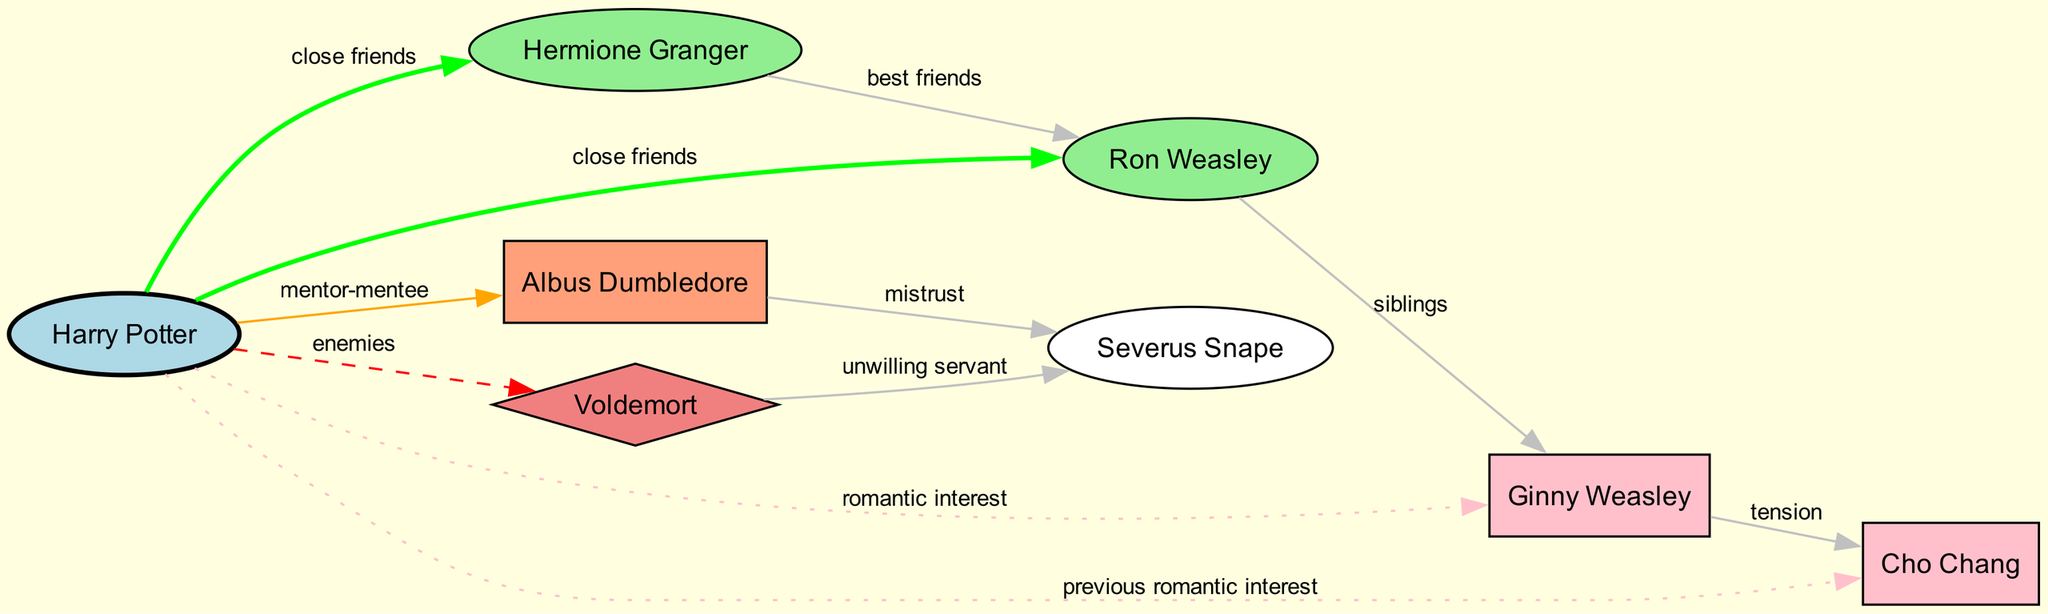What is the label of the node representing Harry Potter? The node for Harry Potter is indicated by the label "Harry Potter". This information can be found directly in the nodes section of the diagram.
Answer: Harry Potter How many nodes are present in the diagram? The total number of nodes listed in the provided data is 8. This includes various characters such as Harry Potter, Hermione Granger, Ron Weasley, etc.
Answer: 8 What type of relationship exists between Harry Potter and Hermione Granger? The diagram shows that Harry Potter and Hermione Granger have a "close friends" relationship, as indicated by the edge connecting them with that specific label.
Answer: close friends What is the relationship between Albus Dumbledore and Severus Snape? According to the diagram, the relationship between Albus Dumbledore and Severus Snape is labeled as "mistrust". This can be seen from the directed edge connecting these two nodes.
Answer: mistrust Who are the best friends mentioned in the diagram? The diagram specifically identifies Hermione Granger and Ron Weasley as best friends, as indicated by the edge labeled "best friends" connecting them.
Answer: Hermione Granger, Ron Weasley Which character is identified as the antagonist? The diagram clearly labels "Voldemort" as the antagonist, which can be seen from the corresponding node.
Answer: Voldemort What tension exists between the love interests in the diagram? There is a "tension" relationship indicated between Ginny Weasley and Cho Chang. This is represented by the edge connecting the two nodes with the label "tension".
Answer: tension How many friend relationships are depicted in the diagram? Counting the edges labeled as various types of friend relationships (close friends and best friends), there are a total of 3 friend connections: Harry with Hermione, Harry with Ron, and Hermione with Ron.
Answer: 3 What type of character is depicted by the "antagonist" node? The antagonist node is represented by Voldemort, who is identified as a character that opposes the protagonist, and is labeled accordingly in the diagram.
Answer: Voldemort What influences the relationship dynamics of Harry Potter? The relationship dynamics of Harry Potter are influenced by multiple characters and their relationships, especially those of his friends, mentors, and love interests, creating a complex network of interactions as illustrated in the diagram.
Answer: Multiple characters 